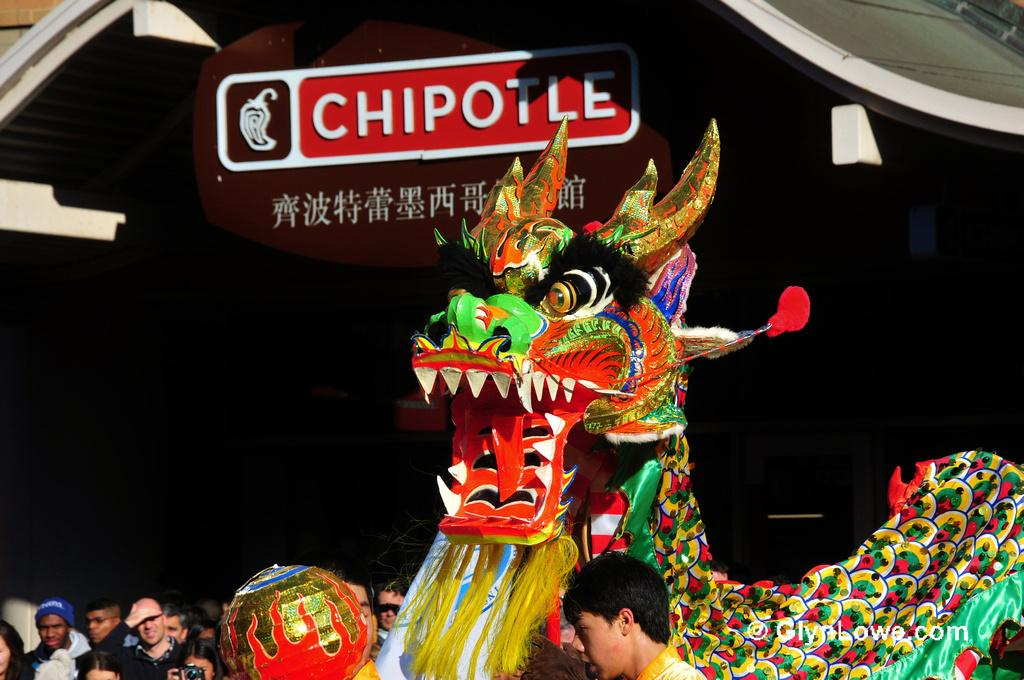Who or what can be seen in the image? There are people in the image. What type of toy is present in the image? There is a toy dragon in the image. Can you describe the appearance of the toy dragon? The toy dragon is colorful. What color is the background of the image? The background of the image is black. What other object can be seen in the image? There is a brown board in the image. How does the cork contribute to the comfort of the people in the image? There is no cork present in the image, so it cannot contribute to the comfort of the people. 